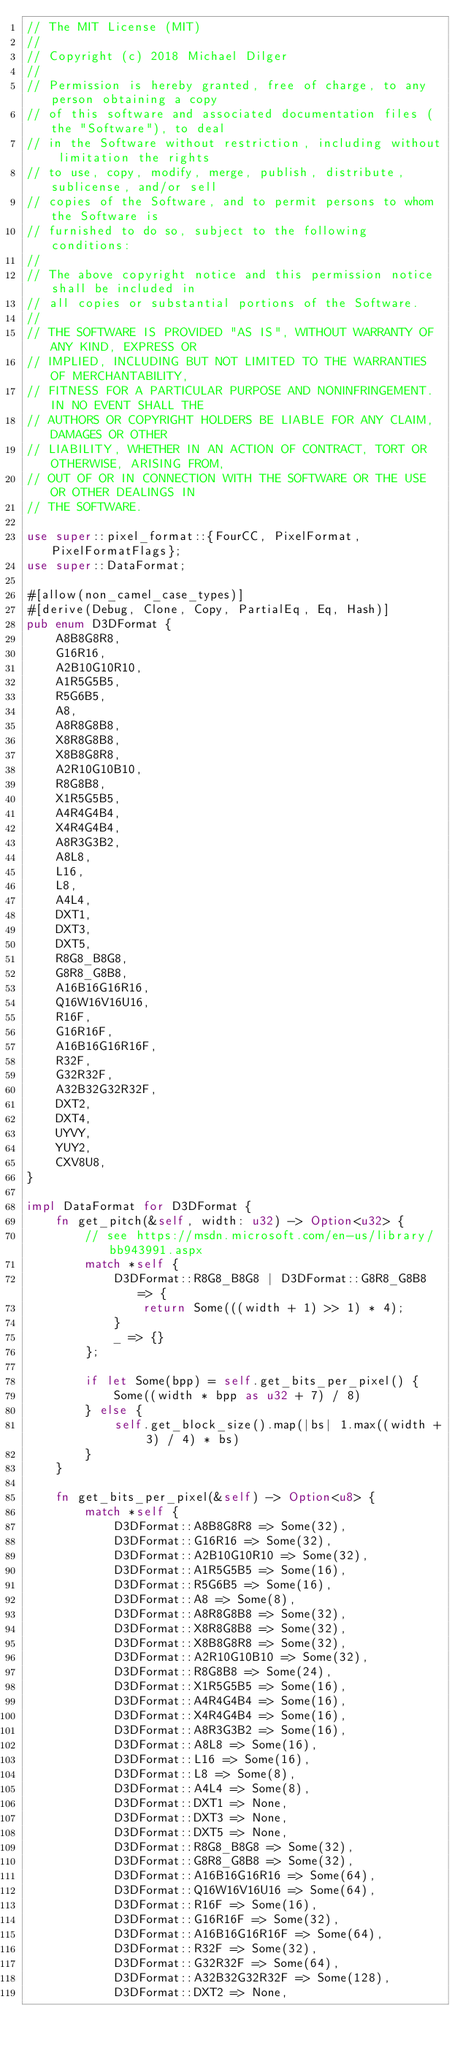<code> <loc_0><loc_0><loc_500><loc_500><_Rust_>// The MIT License (MIT)
//
// Copyright (c) 2018 Michael Dilger
//
// Permission is hereby granted, free of charge, to any person obtaining a copy
// of this software and associated documentation files (the "Software"), to deal
// in the Software without restriction, including without limitation the rights
// to use, copy, modify, merge, publish, distribute, sublicense, and/or sell
// copies of the Software, and to permit persons to whom the Software is
// furnished to do so, subject to the following conditions:
//
// The above copyright notice and this permission notice shall be included in
// all copies or substantial portions of the Software.
//
// THE SOFTWARE IS PROVIDED "AS IS", WITHOUT WARRANTY OF ANY KIND, EXPRESS OR
// IMPLIED, INCLUDING BUT NOT LIMITED TO THE WARRANTIES OF MERCHANTABILITY,
// FITNESS FOR A PARTICULAR PURPOSE AND NONINFRINGEMENT. IN NO EVENT SHALL THE
// AUTHORS OR COPYRIGHT HOLDERS BE LIABLE FOR ANY CLAIM, DAMAGES OR OTHER
// LIABILITY, WHETHER IN AN ACTION OF CONTRACT, TORT OR OTHERWISE, ARISING FROM,
// OUT OF OR IN CONNECTION WITH THE SOFTWARE OR THE USE OR OTHER DEALINGS IN
// THE SOFTWARE.

use super::pixel_format::{FourCC, PixelFormat, PixelFormatFlags};
use super::DataFormat;

#[allow(non_camel_case_types)]
#[derive(Debug, Clone, Copy, PartialEq, Eq, Hash)]
pub enum D3DFormat {
    A8B8G8R8,
    G16R16,
    A2B10G10R10,
    A1R5G5B5,
    R5G6B5,
    A8,
    A8R8G8B8,
    X8R8G8B8,
    X8B8G8R8,
    A2R10G10B10,
    R8G8B8,
    X1R5G5B5,
    A4R4G4B4,
    X4R4G4B4,
    A8R3G3B2,
    A8L8,
    L16,
    L8,
    A4L4,
    DXT1,
    DXT3,
    DXT5,
    R8G8_B8G8,
    G8R8_G8B8,
    A16B16G16R16,
    Q16W16V16U16,
    R16F,
    G16R16F,
    A16B16G16R16F,
    R32F,
    G32R32F,
    A32B32G32R32F,
    DXT2,
    DXT4,
    UYVY,
    YUY2,
    CXV8U8,
}

impl DataFormat for D3DFormat {
    fn get_pitch(&self, width: u32) -> Option<u32> {
        // see https://msdn.microsoft.com/en-us/library/bb943991.aspx
        match *self {
            D3DFormat::R8G8_B8G8 | D3DFormat::G8R8_G8B8 => {
                return Some(((width + 1) >> 1) * 4);
            }
            _ => {}
        };

        if let Some(bpp) = self.get_bits_per_pixel() {
            Some((width * bpp as u32 + 7) / 8)
        } else {
            self.get_block_size().map(|bs| 1.max((width + 3) / 4) * bs)
        }
    }

    fn get_bits_per_pixel(&self) -> Option<u8> {
        match *self {
            D3DFormat::A8B8G8R8 => Some(32),
            D3DFormat::G16R16 => Some(32),
            D3DFormat::A2B10G10R10 => Some(32),
            D3DFormat::A1R5G5B5 => Some(16),
            D3DFormat::R5G6B5 => Some(16),
            D3DFormat::A8 => Some(8),
            D3DFormat::A8R8G8B8 => Some(32),
            D3DFormat::X8R8G8B8 => Some(32),
            D3DFormat::X8B8G8R8 => Some(32),
            D3DFormat::A2R10G10B10 => Some(32),
            D3DFormat::R8G8B8 => Some(24),
            D3DFormat::X1R5G5B5 => Some(16),
            D3DFormat::A4R4G4B4 => Some(16),
            D3DFormat::X4R4G4B4 => Some(16),
            D3DFormat::A8R3G3B2 => Some(16),
            D3DFormat::A8L8 => Some(16),
            D3DFormat::L16 => Some(16),
            D3DFormat::L8 => Some(8),
            D3DFormat::A4L4 => Some(8),
            D3DFormat::DXT1 => None,
            D3DFormat::DXT3 => None,
            D3DFormat::DXT5 => None,
            D3DFormat::R8G8_B8G8 => Some(32),
            D3DFormat::G8R8_G8B8 => Some(32),
            D3DFormat::A16B16G16R16 => Some(64),
            D3DFormat::Q16W16V16U16 => Some(64),
            D3DFormat::R16F => Some(16),
            D3DFormat::G16R16F => Some(32),
            D3DFormat::A16B16G16R16F => Some(64),
            D3DFormat::R32F => Some(32),
            D3DFormat::G32R32F => Some(64),
            D3DFormat::A32B32G32R32F => Some(128),
            D3DFormat::DXT2 => None,</code> 